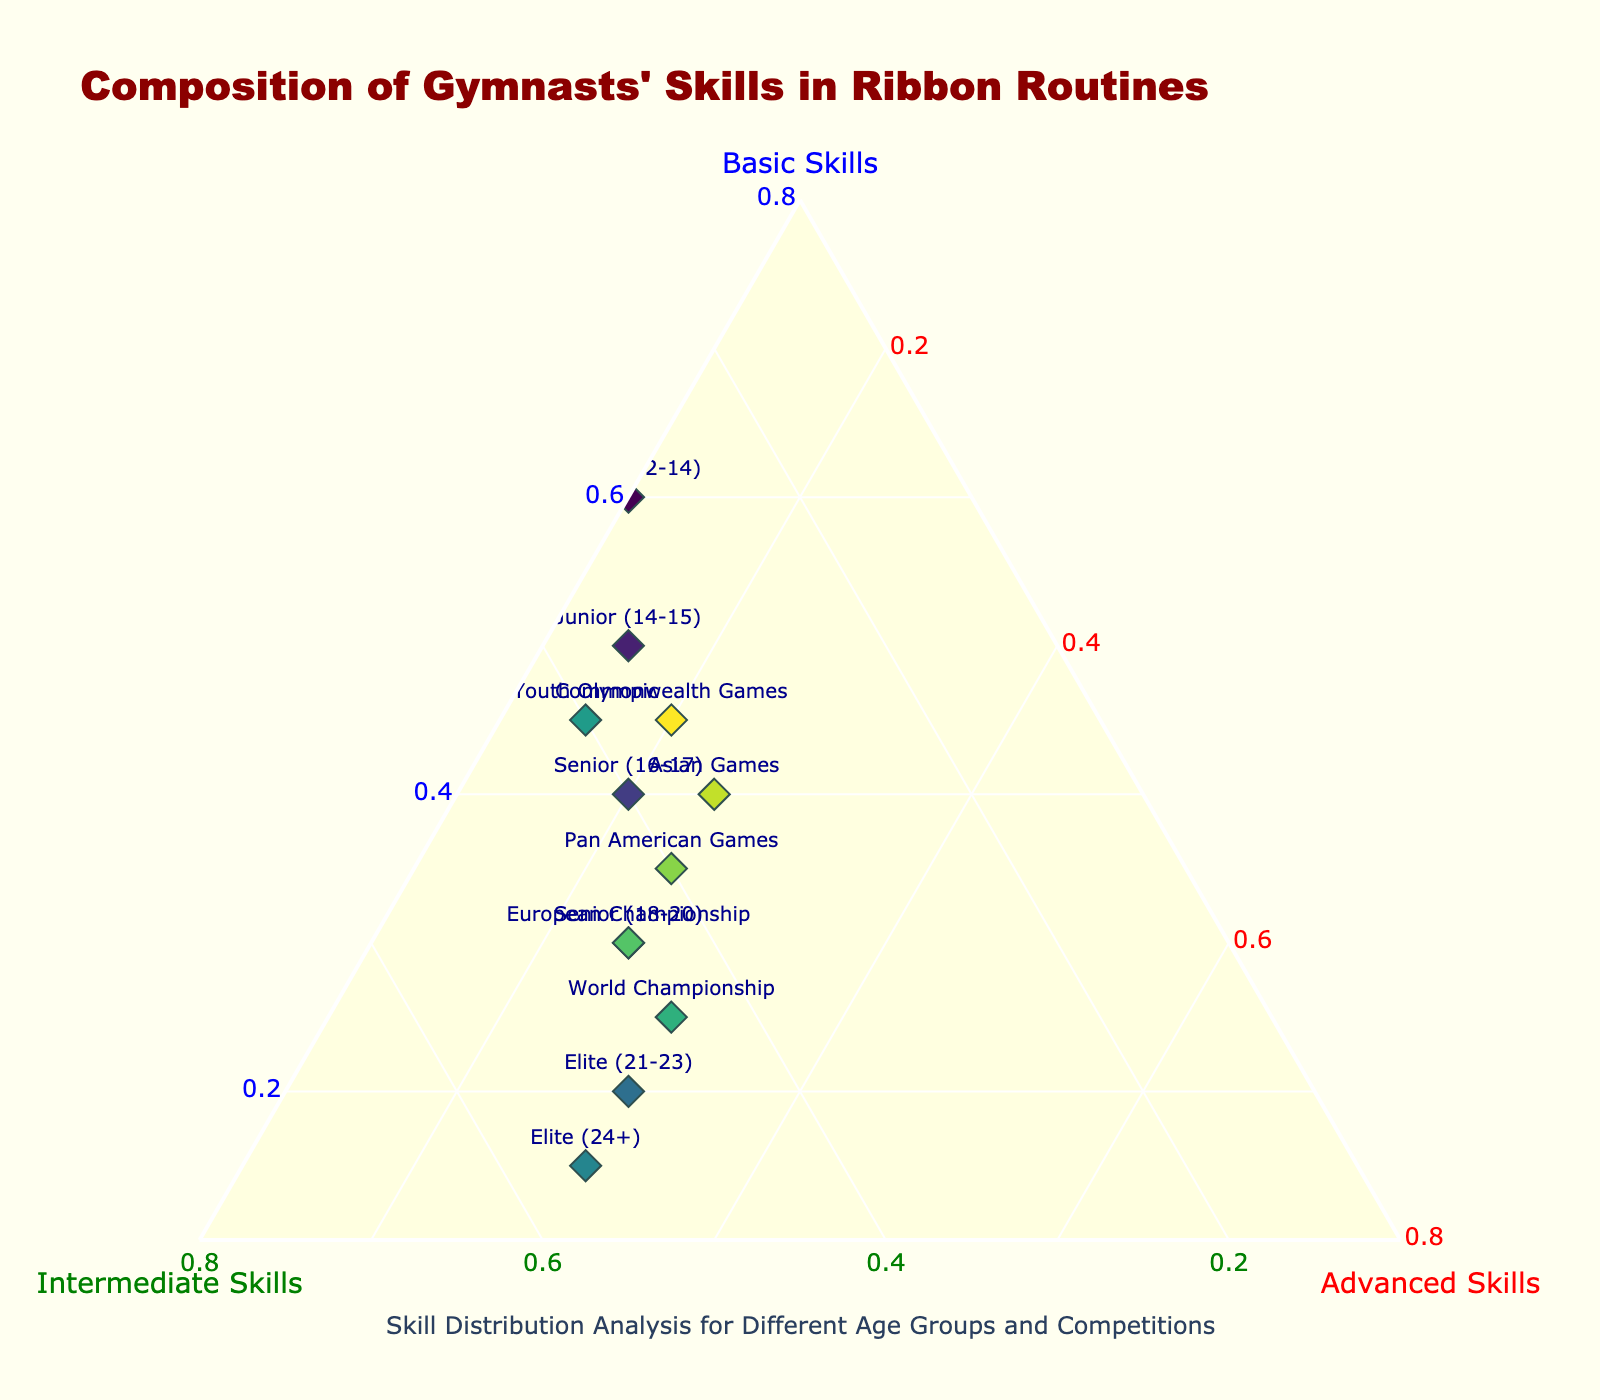How many age groups and competitions are displayed in the figure? To find the number of age groups and competitions, count the number of labels in the figure. Each label represents either an age group or a competition.
Answer: 12 What is the composition of skills for the 'European Championship' group? Locate the 'European Championship' label in the figure and read the values for Basic, Intermediate, and Advanced Skills from the hovertemplate provided.
Answer: 30% Basic, 45% Intermediate, 25% Advanced Which group has the highest percentage of Basic Skills? Identify the group with the highest 'a' value (Basic Skills) in the figure.
Answer: Junior (12-14) Compare the Intermediate Skills between 'Junior (14-15)' and 'World Championship'. Which group has a higher percentage? Locate the 'Junior (14-15)' and 'World Championship' points in the figure. Compare their 'b' values (Intermediate Skills).
Answer: World Championship What is the average percentage of Intermediate Skills across all groups? Calculate the average by summing the 'b' values (Intermediate Skills) of all groups and then divide by the number of groups.
Answer: 41.67% In which age group do we see an equal percentage of Basic and Intermediate Skills? Locate the group where 'a' and 'b' values are equal in the figure.
Answer: Senior (16-17) How does the percentage of Advanced Skills change as gymnasts age? Observe the trend of 'c' values (Advanced Skills) from younger to older age groups and competitions.
Answer: Increases Which group has the most balanced composition of Basic, Intermediate, and Advanced Skills? Look for the group where 'a', 'b', and 'c' are most similar.
Answer: Youth Olympic What is the skill composition for the 'Elite (21-23)' group? Locate the 'Elite (21-23)' label in the figure and read the values for Basic, Intermediate, and Advanced Skills from the hovertemplate provided.
Answer: 20% Basic, 50% Intermediate, 30% Advanced Is there any group with a higher percentage of Intermediate Skills than Basic Skills and Advanced Skills combined? Check if there is any group where the 'b' value (Intermediate Skills) is greater than the sum of 'a' (Basic Skills) and 'c' (Advanced Skills).
Answer: No 